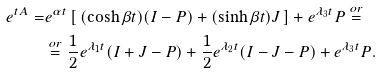<formula> <loc_0><loc_0><loc_500><loc_500>e ^ { t A } = & e ^ { \alpha t } \left [ \, ( \cosh { \beta t } ) ( I - P ) + ( \sinh { \beta t } ) J \, \right ] + e ^ { \lambda _ { 3 } t } P \overset { o r } = \\ & \overset { o r } = \frac { 1 } { 2 } e ^ { \lambda _ { 1 } t } ( I + J - P ) + \frac { 1 } { 2 } e ^ { \lambda _ { 2 } t } ( I - J - P ) + e ^ { \lambda _ { 3 } t } P .</formula> 